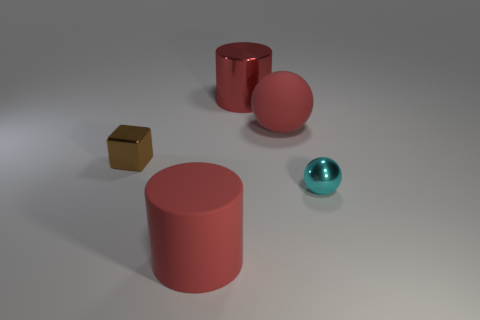There is a large red metal cylinder; how many large rubber objects are on the left side of it?
Ensure brevity in your answer.  1. Is there any other thing that is the same material as the red ball?
Make the answer very short. Yes. Do the small brown shiny thing to the left of the big ball and the tiny cyan object have the same shape?
Your answer should be compact. No. There is a small metallic thing that is left of the large sphere; what color is it?
Offer a very short reply. Brown. There is another small object that is made of the same material as the tiny brown object; what shape is it?
Make the answer very short. Sphere. Are there any other things that are the same color as the metallic block?
Offer a terse response. No. Are there more rubber spheres that are on the left side of the big shiny cylinder than big spheres in front of the tiny brown object?
Make the answer very short. No. How many cyan things are the same size as the rubber sphere?
Make the answer very short. 0. Are there fewer large shiny things in front of the red ball than red matte things that are right of the big metal cylinder?
Make the answer very short. Yes. Are there any tiny gray things of the same shape as the cyan object?
Your answer should be compact. No. 